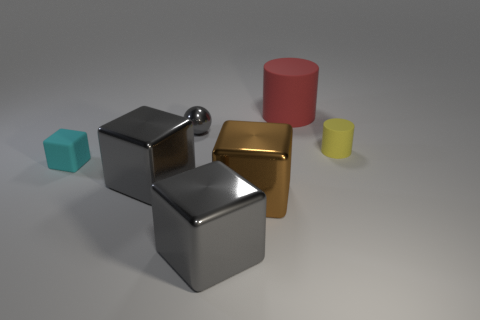Add 1 purple things. How many objects exist? 8 Subtract all blocks. How many objects are left? 3 Add 4 big red rubber things. How many big red rubber things exist? 5 Subtract 0 green cylinders. How many objects are left? 7 Subtract all tiny yellow objects. Subtract all shiny spheres. How many objects are left? 5 Add 3 red matte cylinders. How many red matte cylinders are left? 4 